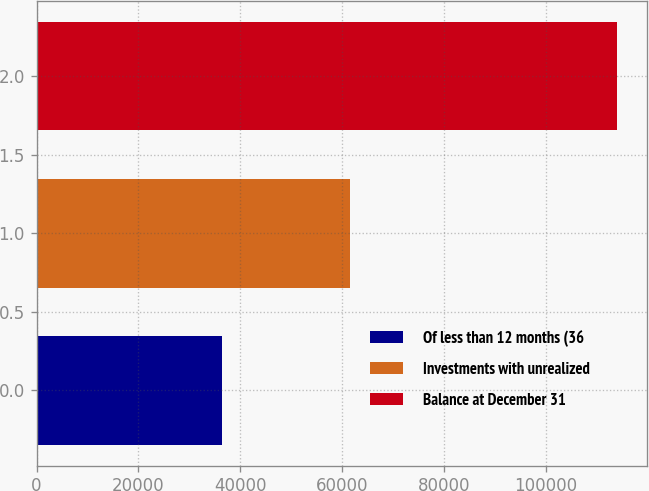Convert chart. <chart><loc_0><loc_0><loc_500><loc_500><bar_chart><fcel>Of less than 12 months (36<fcel>Investments with unrealized<fcel>Balance at December 31<nl><fcel>36436<fcel>61638<fcel>114075<nl></chart> 